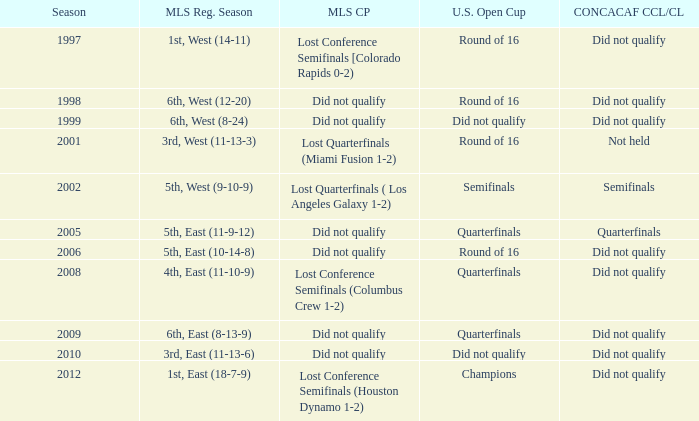How did the team place when they did not qualify for the Concaf Champions Cup but made it to Round of 16 in the U.S. Open Cup? Lost Conference Semifinals [Colorado Rapids 0-2), Did not qualify, Did not qualify. 